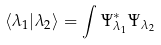Convert formula to latex. <formula><loc_0><loc_0><loc_500><loc_500>\left < \lambda _ { 1 } | \lambda _ { 2 } \right > = \int \Psi ^ { * } _ { \lambda _ { 1 } } \Psi _ { \lambda _ { 2 } }</formula> 